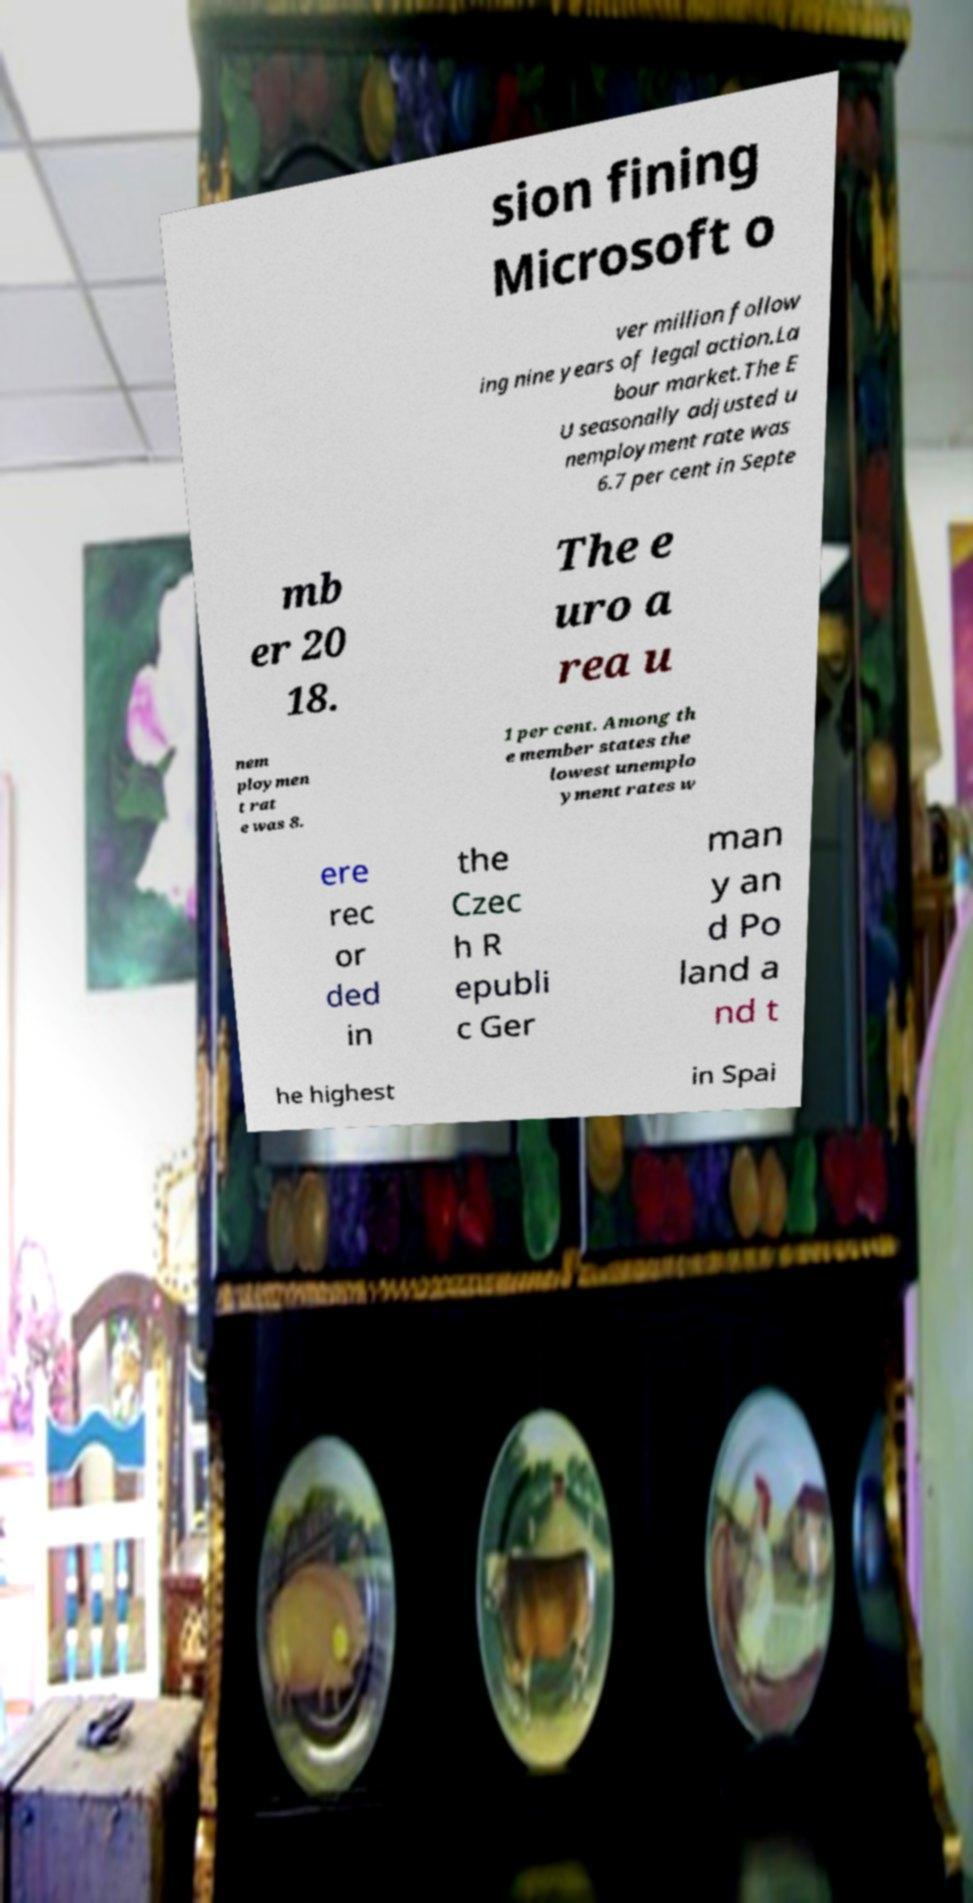What messages or text are displayed in this image? I need them in a readable, typed format. sion fining Microsoft o ver million follow ing nine years of legal action.La bour market.The E U seasonally adjusted u nemployment rate was 6.7 per cent in Septe mb er 20 18. The e uro a rea u nem ploymen t rat e was 8. 1 per cent. Among th e member states the lowest unemplo yment rates w ere rec or ded in the Czec h R epubli c Ger man y an d Po land a nd t he highest in Spai 